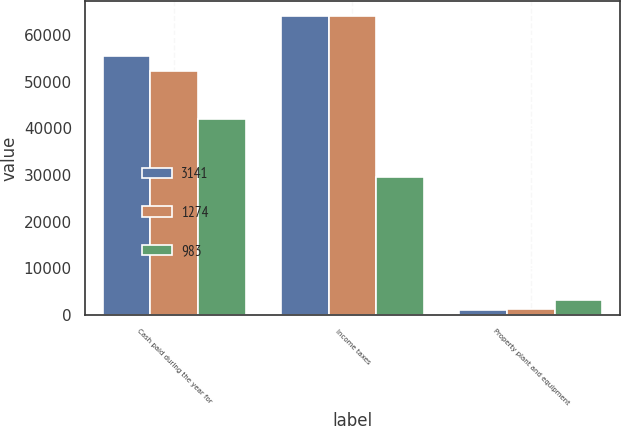<chart> <loc_0><loc_0><loc_500><loc_500><stacked_bar_chart><ecel><fcel>Cash paid during the year for<fcel>Income taxes<fcel>Property plant and equipment<nl><fcel>3141<fcel>55522<fcel>64120<fcel>983<nl><fcel>1274<fcel>52268<fcel>64092<fcel>1274<nl><fcel>983<fcel>41966<fcel>29565<fcel>3141<nl></chart> 